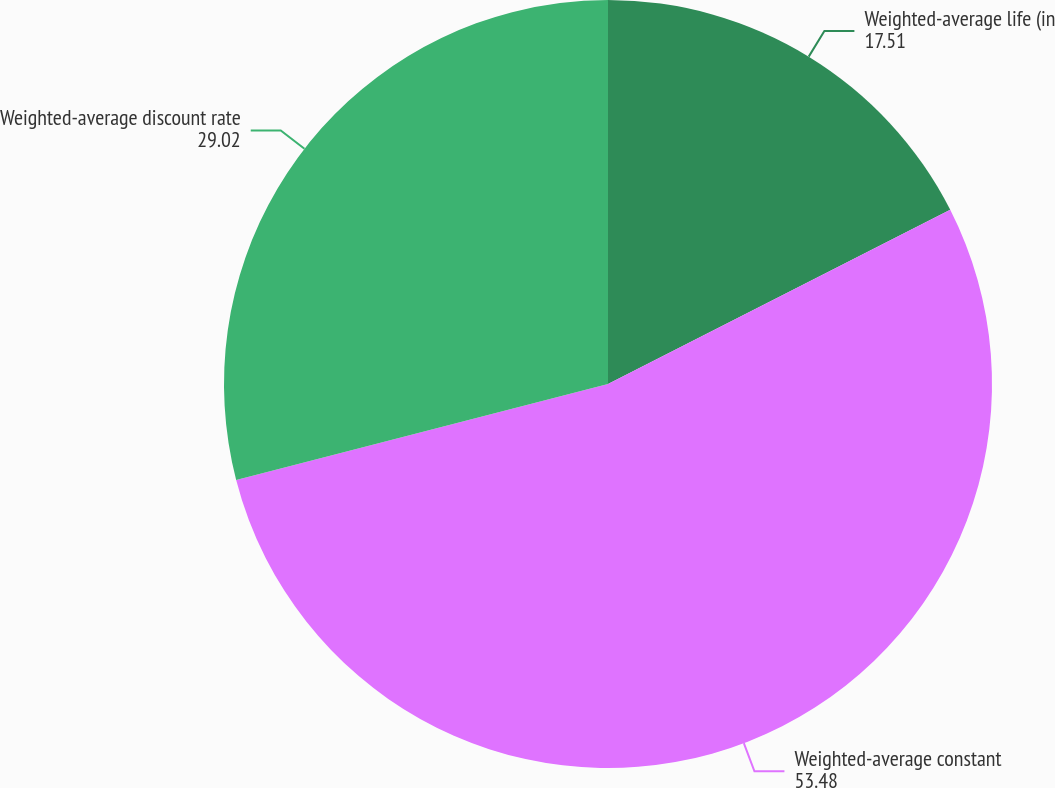Convert chart. <chart><loc_0><loc_0><loc_500><loc_500><pie_chart><fcel>Weighted-average life (in<fcel>Weighted-average constant<fcel>Weighted-average discount rate<nl><fcel>17.51%<fcel>53.48%<fcel>29.02%<nl></chart> 